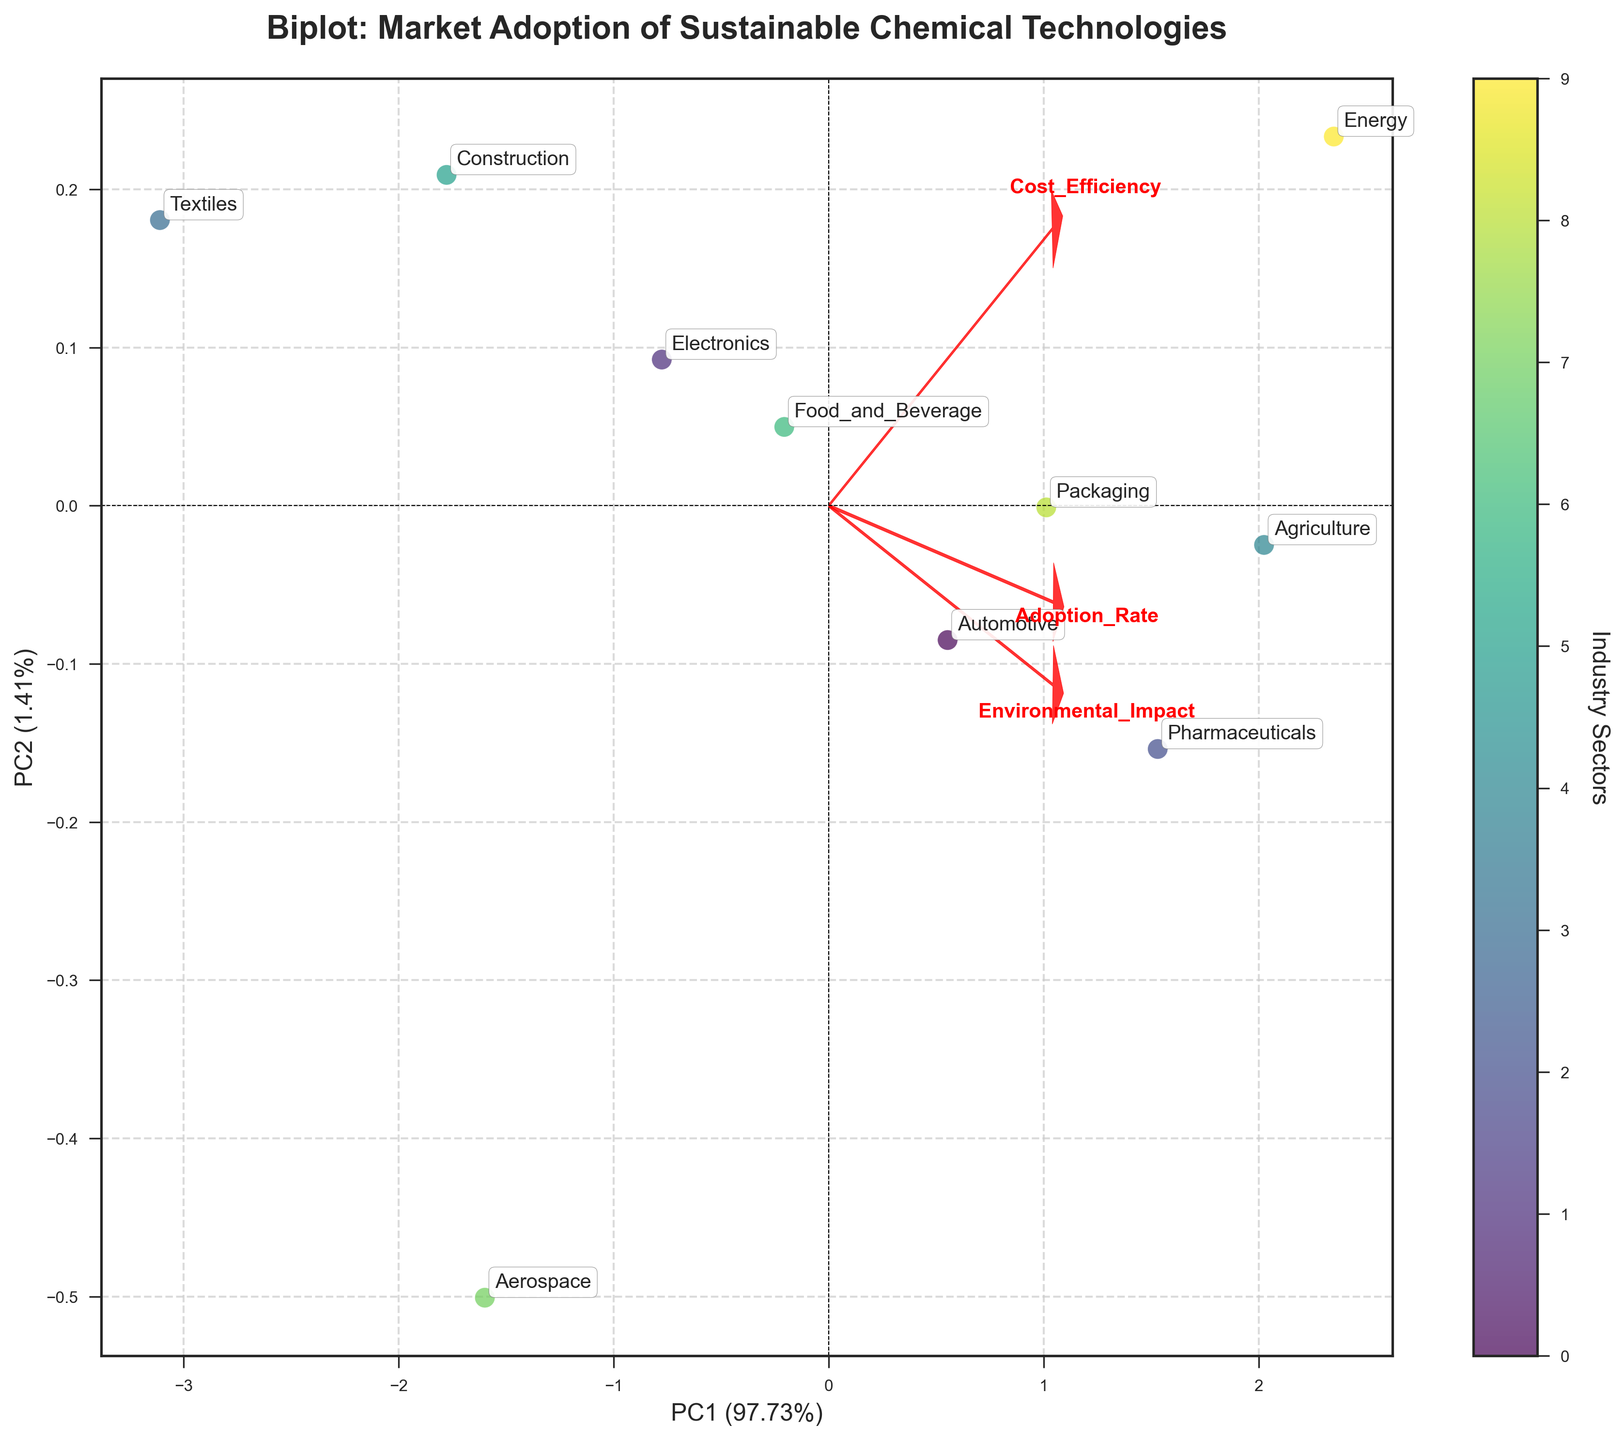What is the title of the figure? The title is displayed at the top center of the plot, reading "Biplot: Market Adoption of Sustainable Chemical Technologies".
Answer: Biplot: Market Adoption of Sustainable Chemical Technologies How many industry sectors are represented in the biplot? Each data point in the biplot represents an industry sector, which are labeled and marked with individual points. Counting the labels gives a total of 10 industry sectors.
Answer: 10 Which industry sector has the highest adoption rate according to the biplot? By looking at the positions of the data points and matching them with the corresponding labels, the "Energy" sector is situated farthest along the direction indicated by the "Adoption Rate" feature arrow, implying it has the highest adoption rate.
Answer: Energy Which feature has the smallest impact correlation with PC1? The direction and length of the feature arrow represent the correlation. The "Environmental Impact" arrow is positioned almost entirely along the PC2 axis, showing minimal correlation with PC1.
Answer: Environmental Impact What's the approximate percentage variance explained by PC1 and PC2 combined? The x-axis label indicates PC1 explains about 78% and the y-axis label shows PC2 explains about 18%. Summing these gives approximately 96%.
Answer: ~96% Which two industry sectors are closest to each other in the biplot? By inspecting the positions of the points on the plot, the "Electronics" and "Packaging" sectors are situated nearest to each other.
Answer: Electronics and Packaging How does the "Food_and_Beverage" sector compare to the "Automotive" sector in terms of adoption rate and cost efficiency? The "Food_and_Beverage" sector is lower along the adoption rate arrow but positioned closer to the cost efficiency arrow, indicating it has a lower adoption rate but relatively better cost efficiency compared to the "Automotive" sector.
Answer: Lower adoption rate, better cost efficiency What direction does the "Adoption Rate" feature arrow point towards in the biplot? Observing the plot, the "Adoption Rate" feature arrow points primarily to the right and slightly upwards, indicating high values are associated with high scores in both PC1 and PC2 directions.
Answer: Right and slight upwards Which industry sector falls closest to the origin in terms of principal component scores? By examining the plot, the "Aerospace" sector data point is closest to the origin (0,0) on the biplot.
Answer: Aerospace How do the "Agriculture" and "Construction" sectors compare in terms of environmental impact? The position along the "Environmental Impact" arrow, which points upwards, shows that "Agriculture" is farther along the arrow compared to "Construction", indicating a higher environmental impact for "Agriculture" than "Construction".
Answer: Agriculture has higher environmental impact than Construction 